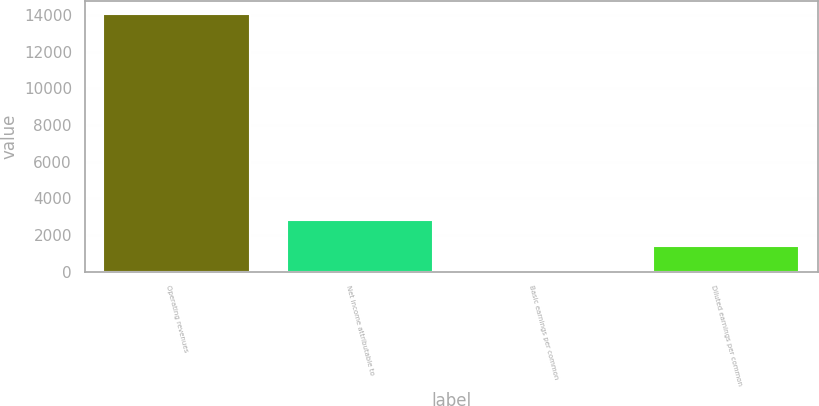Convert chart to OTSL. <chart><loc_0><loc_0><loc_500><loc_500><bar_chart><fcel>Operating revenues<fcel>Net income attributable to<fcel>Basic earnings per common<fcel>Diluted earnings per common<nl><fcel>14085<fcel>2817.2<fcel>0.24<fcel>1408.72<nl></chart> 